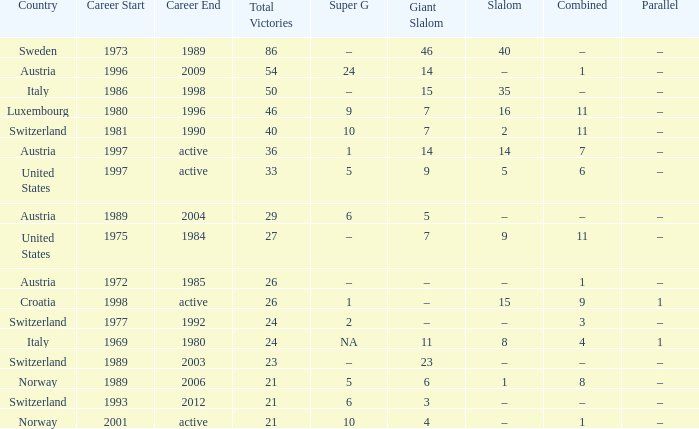What Super G has Victories of 26, and a Country of austria? –. 